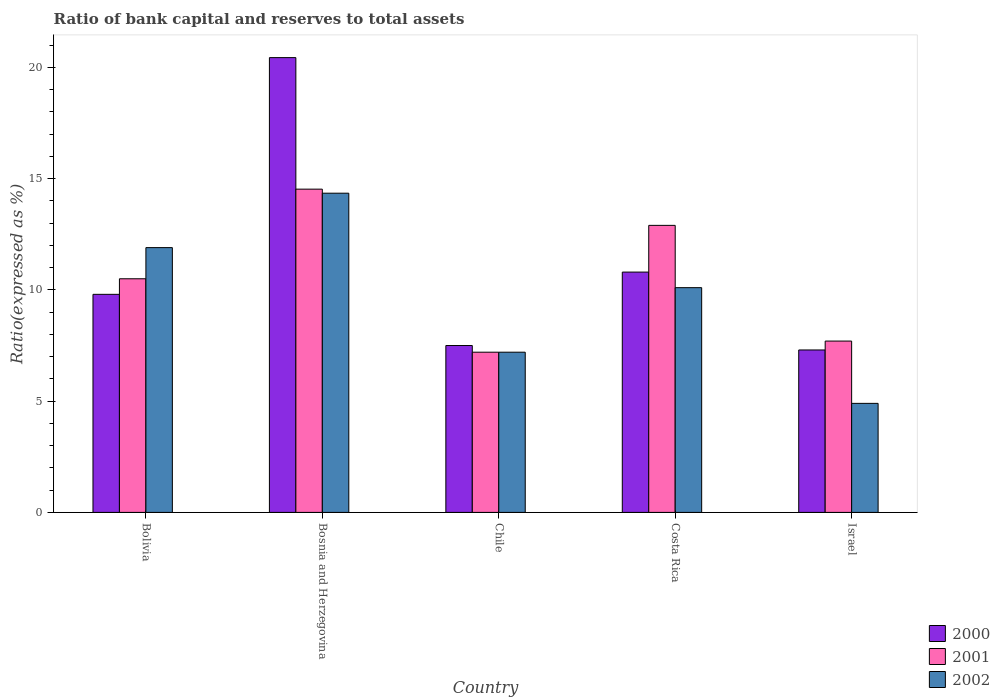Are the number of bars per tick equal to the number of legend labels?
Your response must be concise. Yes. In how many cases, is the number of bars for a given country not equal to the number of legend labels?
Provide a succinct answer. 0. Across all countries, what is the maximum ratio of bank capital and reserves to total assets in 2000?
Your answer should be very brief. 20.44. In which country was the ratio of bank capital and reserves to total assets in 2001 maximum?
Offer a terse response. Bosnia and Herzegovina. In which country was the ratio of bank capital and reserves to total assets in 2000 minimum?
Make the answer very short. Israel. What is the total ratio of bank capital and reserves to total assets in 2002 in the graph?
Your answer should be very brief. 48.45. What is the difference between the ratio of bank capital and reserves to total assets in 2001 in Chile and that in Costa Rica?
Your answer should be compact. -5.7. What is the difference between the ratio of bank capital and reserves to total assets in 2000 in Bosnia and Herzegovina and the ratio of bank capital and reserves to total assets in 2002 in Bolivia?
Your answer should be compact. 8.54. What is the average ratio of bank capital and reserves to total assets in 2002 per country?
Provide a short and direct response. 9.69. What is the difference between the ratio of bank capital and reserves to total assets of/in 2001 and ratio of bank capital and reserves to total assets of/in 2000 in Costa Rica?
Offer a terse response. 2.1. In how many countries, is the ratio of bank capital and reserves to total assets in 2002 greater than 4 %?
Provide a short and direct response. 5. What is the ratio of the ratio of bank capital and reserves to total assets in 2000 in Bosnia and Herzegovina to that in Costa Rica?
Offer a terse response. 1.89. What is the difference between the highest and the lowest ratio of bank capital and reserves to total assets in 2001?
Your answer should be compact. 7.33. How many countries are there in the graph?
Offer a terse response. 5. What is the difference between two consecutive major ticks on the Y-axis?
Provide a short and direct response. 5. Does the graph contain grids?
Ensure brevity in your answer.  No. Where does the legend appear in the graph?
Your answer should be compact. Bottom right. How many legend labels are there?
Ensure brevity in your answer.  3. How are the legend labels stacked?
Your answer should be compact. Vertical. What is the title of the graph?
Provide a succinct answer. Ratio of bank capital and reserves to total assets. Does "2012" appear as one of the legend labels in the graph?
Give a very brief answer. No. What is the label or title of the X-axis?
Keep it short and to the point. Country. What is the label or title of the Y-axis?
Ensure brevity in your answer.  Ratio(expressed as %). What is the Ratio(expressed as %) in 2000 in Bolivia?
Your response must be concise. 9.8. What is the Ratio(expressed as %) of 2000 in Bosnia and Herzegovina?
Your answer should be very brief. 20.44. What is the Ratio(expressed as %) of 2001 in Bosnia and Herzegovina?
Make the answer very short. 14.53. What is the Ratio(expressed as %) of 2002 in Bosnia and Herzegovina?
Provide a succinct answer. 14.35. What is the Ratio(expressed as %) in 2000 in Chile?
Your answer should be compact. 7.5. What is the Ratio(expressed as %) in 2002 in Costa Rica?
Make the answer very short. 10.1. What is the Ratio(expressed as %) of 2001 in Israel?
Your response must be concise. 7.7. Across all countries, what is the maximum Ratio(expressed as %) of 2000?
Keep it short and to the point. 20.44. Across all countries, what is the maximum Ratio(expressed as %) of 2001?
Your answer should be compact. 14.53. Across all countries, what is the maximum Ratio(expressed as %) of 2002?
Ensure brevity in your answer.  14.35. Across all countries, what is the minimum Ratio(expressed as %) in 2001?
Ensure brevity in your answer.  7.2. Across all countries, what is the minimum Ratio(expressed as %) of 2002?
Give a very brief answer. 4.9. What is the total Ratio(expressed as %) in 2000 in the graph?
Provide a short and direct response. 55.84. What is the total Ratio(expressed as %) of 2001 in the graph?
Your answer should be compact. 52.83. What is the total Ratio(expressed as %) of 2002 in the graph?
Ensure brevity in your answer.  48.45. What is the difference between the Ratio(expressed as %) in 2000 in Bolivia and that in Bosnia and Herzegovina?
Your answer should be very brief. -10.64. What is the difference between the Ratio(expressed as %) of 2001 in Bolivia and that in Bosnia and Herzegovina?
Your answer should be very brief. -4.03. What is the difference between the Ratio(expressed as %) of 2002 in Bolivia and that in Bosnia and Herzegovina?
Keep it short and to the point. -2.45. What is the difference between the Ratio(expressed as %) of 2001 in Bolivia and that in Chile?
Keep it short and to the point. 3.3. What is the difference between the Ratio(expressed as %) in 2002 in Bolivia and that in Chile?
Make the answer very short. 4.7. What is the difference between the Ratio(expressed as %) of 2000 in Bolivia and that in Costa Rica?
Offer a very short reply. -1. What is the difference between the Ratio(expressed as %) in 2001 in Bolivia and that in Costa Rica?
Offer a very short reply. -2.4. What is the difference between the Ratio(expressed as %) in 2002 in Bolivia and that in Costa Rica?
Provide a succinct answer. 1.8. What is the difference between the Ratio(expressed as %) in 2000 in Bosnia and Herzegovina and that in Chile?
Offer a very short reply. 12.94. What is the difference between the Ratio(expressed as %) of 2001 in Bosnia and Herzegovina and that in Chile?
Offer a terse response. 7.33. What is the difference between the Ratio(expressed as %) of 2002 in Bosnia and Herzegovina and that in Chile?
Give a very brief answer. 7.15. What is the difference between the Ratio(expressed as %) of 2000 in Bosnia and Herzegovina and that in Costa Rica?
Ensure brevity in your answer.  9.64. What is the difference between the Ratio(expressed as %) in 2001 in Bosnia and Herzegovina and that in Costa Rica?
Offer a very short reply. 1.63. What is the difference between the Ratio(expressed as %) of 2002 in Bosnia and Herzegovina and that in Costa Rica?
Offer a very short reply. 4.25. What is the difference between the Ratio(expressed as %) in 2000 in Bosnia and Herzegovina and that in Israel?
Provide a succinct answer. 13.14. What is the difference between the Ratio(expressed as %) of 2001 in Bosnia and Herzegovina and that in Israel?
Ensure brevity in your answer.  6.83. What is the difference between the Ratio(expressed as %) in 2002 in Bosnia and Herzegovina and that in Israel?
Make the answer very short. 9.45. What is the difference between the Ratio(expressed as %) in 2000 in Chile and that in Costa Rica?
Keep it short and to the point. -3.3. What is the difference between the Ratio(expressed as %) of 2002 in Chile and that in Costa Rica?
Offer a very short reply. -2.9. What is the difference between the Ratio(expressed as %) in 2000 in Chile and that in Israel?
Your answer should be compact. 0.2. What is the difference between the Ratio(expressed as %) in 2002 in Chile and that in Israel?
Keep it short and to the point. 2.3. What is the difference between the Ratio(expressed as %) in 2002 in Costa Rica and that in Israel?
Offer a terse response. 5.2. What is the difference between the Ratio(expressed as %) of 2000 in Bolivia and the Ratio(expressed as %) of 2001 in Bosnia and Herzegovina?
Ensure brevity in your answer.  -4.73. What is the difference between the Ratio(expressed as %) in 2000 in Bolivia and the Ratio(expressed as %) in 2002 in Bosnia and Herzegovina?
Ensure brevity in your answer.  -4.55. What is the difference between the Ratio(expressed as %) of 2001 in Bolivia and the Ratio(expressed as %) of 2002 in Bosnia and Herzegovina?
Your answer should be very brief. -3.85. What is the difference between the Ratio(expressed as %) in 2000 in Bolivia and the Ratio(expressed as %) in 2001 in Chile?
Your response must be concise. 2.6. What is the difference between the Ratio(expressed as %) of 2001 in Bolivia and the Ratio(expressed as %) of 2002 in Chile?
Give a very brief answer. 3.3. What is the difference between the Ratio(expressed as %) of 2000 in Bolivia and the Ratio(expressed as %) of 2001 in Costa Rica?
Provide a succinct answer. -3.1. What is the difference between the Ratio(expressed as %) in 2000 in Bolivia and the Ratio(expressed as %) in 2002 in Israel?
Offer a terse response. 4.9. What is the difference between the Ratio(expressed as %) of 2001 in Bolivia and the Ratio(expressed as %) of 2002 in Israel?
Provide a short and direct response. 5.6. What is the difference between the Ratio(expressed as %) of 2000 in Bosnia and Herzegovina and the Ratio(expressed as %) of 2001 in Chile?
Offer a very short reply. 13.24. What is the difference between the Ratio(expressed as %) in 2000 in Bosnia and Herzegovina and the Ratio(expressed as %) in 2002 in Chile?
Make the answer very short. 13.24. What is the difference between the Ratio(expressed as %) of 2001 in Bosnia and Herzegovina and the Ratio(expressed as %) of 2002 in Chile?
Ensure brevity in your answer.  7.33. What is the difference between the Ratio(expressed as %) of 2000 in Bosnia and Herzegovina and the Ratio(expressed as %) of 2001 in Costa Rica?
Make the answer very short. 7.54. What is the difference between the Ratio(expressed as %) in 2000 in Bosnia and Herzegovina and the Ratio(expressed as %) in 2002 in Costa Rica?
Your answer should be compact. 10.34. What is the difference between the Ratio(expressed as %) in 2001 in Bosnia and Herzegovina and the Ratio(expressed as %) in 2002 in Costa Rica?
Provide a short and direct response. 4.43. What is the difference between the Ratio(expressed as %) of 2000 in Bosnia and Herzegovina and the Ratio(expressed as %) of 2001 in Israel?
Provide a short and direct response. 12.74. What is the difference between the Ratio(expressed as %) of 2000 in Bosnia and Herzegovina and the Ratio(expressed as %) of 2002 in Israel?
Your answer should be very brief. 15.54. What is the difference between the Ratio(expressed as %) in 2001 in Bosnia and Herzegovina and the Ratio(expressed as %) in 2002 in Israel?
Your answer should be compact. 9.63. What is the difference between the Ratio(expressed as %) in 2000 in Chile and the Ratio(expressed as %) in 2001 in Costa Rica?
Your answer should be compact. -5.4. What is the difference between the Ratio(expressed as %) in 2001 in Chile and the Ratio(expressed as %) in 2002 in Costa Rica?
Provide a short and direct response. -2.9. What is the difference between the Ratio(expressed as %) of 2000 in Chile and the Ratio(expressed as %) of 2001 in Israel?
Make the answer very short. -0.2. What is the difference between the Ratio(expressed as %) in 2000 in Chile and the Ratio(expressed as %) in 2002 in Israel?
Make the answer very short. 2.6. What is the difference between the Ratio(expressed as %) of 2001 in Chile and the Ratio(expressed as %) of 2002 in Israel?
Give a very brief answer. 2.3. What is the difference between the Ratio(expressed as %) in 2000 in Costa Rica and the Ratio(expressed as %) in 2001 in Israel?
Your answer should be compact. 3.1. What is the average Ratio(expressed as %) in 2000 per country?
Your answer should be compact. 11.17. What is the average Ratio(expressed as %) in 2001 per country?
Your answer should be very brief. 10.57. What is the average Ratio(expressed as %) of 2002 per country?
Your answer should be very brief. 9.69. What is the difference between the Ratio(expressed as %) of 2000 and Ratio(expressed as %) of 2001 in Bosnia and Herzegovina?
Offer a terse response. 5.91. What is the difference between the Ratio(expressed as %) in 2000 and Ratio(expressed as %) in 2002 in Bosnia and Herzegovina?
Provide a succinct answer. 6.09. What is the difference between the Ratio(expressed as %) of 2001 and Ratio(expressed as %) of 2002 in Bosnia and Herzegovina?
Your response must be concise. 0.18. What is the difference between the Ratio(expressed as %) of 2000 and Ratio(expressed as %) of 2001 in Chile?
Offer a terse response. 0.3. What is the difference between the Ratio(expressed as %) of 2000 and Ratio(expressed as %) of 2002 in Chile?
Offer a very short reply. 0.3. What is the difference between the Ratio(expressed as %) of 2001 and Ratio(expressed as %) of 2002 in Chile?
Your response must be concise. 0. What is the difference between the Ratio(expressed as %) of 2000 and Ratio(expressed as %) of 2002 in Costa Rica?
Your answer should be compact. 0.7. What is the difference between the Ratio(expressed as %) in 2001 and Ratio(expressed as %) in 2002 in Costa Rica?
Make the answer very short. 2.8. What is the difference between the Ratio(expressed as %) in 2000 and Ratio(expressed as %) in 2002 in Israel?
Provide a succinct answer. 2.4. What is the difference between the Ratio(expressed as %) in 2001 and Ratio(expressed as %) in 2002 in Israel?
Offer a terse response. 2.8. What is the ratio of the Ratio(expressed as %) in 2000 in Bolivia to that in Bosnia and Herzegovina?
Offer a very short reply. 0.48. What is the ratio of the Ratio(expressed as %) in 2001 in Bolivia to that in Bosnia and Herzegovina?
Offer a very short reply. 0.72. What is the ratio of the Ratio(expressed as %) of 2002 in Bolivia to that in Bosnia and Herzegovina?
Provide a succinct answer. 0.83. What is the ratio of the Ratio(expressed as %) of 2000 in Bolivia to that in Chile?
Give a very brief answer. 1.31. What is the ratio of the Ratio(expressed as %) in 2001 in Bolivia to that in Chile?
Your answer should be compact. 1.46. What is the ratio of the Ratio(expressed as %) in 2002 in Bolivia to that in Chile?
Provide a short and direct response. 1.65. What is the ratio of the Ratio(expressed as %) of 2000 in Bolivia to that in Costa Rica?
Your answer should be very brief. 0.91. What is the ratio of the Ratio(expressed as %) of 2001 in Bolivia to that in Costa Rica?
Give a very brief answer. 0.81. What is the ratio of the Ratio(expressed as %) in 2002 in Bolivia to that in Costa Rica?
Give a very brief answer. 1.18. What is the ratio of the Ratio(expressed as %) in 2000 in Bolivia to that in Israel?
Make the answer very short. 1.34. What is the ratio of the Ratio(expressed as %) of 2001 in Bolivia to that in Israel?
Keep it short and to the point. 1.36. What is the ratio of the Ratio(expressed as %) in 2002 in Bolivia to that in Israel?
Keep it short and to the point. 2.43. What is the ratio of the Ratio(expressed as %) of 2000 in Bosnia and Herzegovina to that in Chile?
Offer a very short reply. 2.73. What is the ratio of the Ratio(expressed as %) in 2001 in Bosnia and Herzegovina to that in Chile?
Your response must be concise. 2.02. What is the ratio of the Ratio(expressed as %) of 2002 in Bosnia and Herzegovina to that in Chile?
Keep it short and to the point. 1.99. What is the ratio of the Ratio(expressed as %) in 2000 in Bosnia and Herzegovina to that in Costa Rica?
Your answer should be compact. 1.89. What is the ratio of the Ratio(expressed as %) of 2001 in Bosnia and Herzegovina to that in Costa Rica?
Keep it short and to the point. 1.13. What is the ratio of the Ratio(expressed as %) in 2002 in Bosnia and Herzegovina to that in Costa Rica?
Your answer should be compact. 1.42. What is the ratio of the Ratio(expressed as %) in 2000 in Bosnia and Herzegovina to that in Israel?
Your answer should be compact. 2.8. What is the ratio of the Ratio(expressed as %) of 2001 in Bosnia and Herzegovina to that in Israel?
Your response must be concise. 1.89. What is the ratio of the Ratio(expressed as %) in 2002 in Bosnia and Herzegovina to that in Israel?
Offer a terse response. 2.93. What is the ratio of the Ratio(expressed as %) in 2000 in Chile to that in Costa Rica?
Provide a succinct answer. 0.69. What is the ratio of the Ratio(expressed as %) of 2001 in Chile to that in Costa Rica?
Give a very brief answer. 0.56. What is the ratio of the Ratio(expressed as %) in 2002 in Chile to that in Costa Rica?
Your response must be concise. 0.71. What is the ratio of the Ratio(expressed as %) in 2000 in Chile to that in Israel?
Make the answer very short. 1.03. What is the ratio of the Ratio(expressed as %) of 2001 in Chile to that in Israel?
Give a very brief answer. 0.94. What is the ratio of the Ratio(expressed as %) in 2002 in Chile to that in Israel?
Your answer should be very brief. 1.47. What is the ratio of the Ratio(expressed as %) of 2000 in Costa Rica to that in Israel?
Provide a short and direct response. 1.48. What is the ratio of the Ratio(expressed as %) in 2001 in Costa Rica to that in Israel?
Keep it short and to the point. 1.68. What is the ratio of the Ratio(expressed as %) of 2002 in Costa Rica to that in Israel?
Ensure brevity in your answer.  2.06. What is the difference between the highest and the second highest Ratio(expressed as %) of 2000?
Give a very brief answer. 9.64. What is the difference between the highest and the second highest Ratio(expressed as %) of 2001?
Provide a short and direct response. 1.63. What is the difference between the highest and the second highest Ratio(expressed as %) of 2002?
Provide a short and direct response. 2.45. What is the difference between the highest and the lowest Ratio(expressed as %) of 2000?
Ensure brevity in your answer.  13.14. What is the difference between the highest and the lowest Ratio(expressed as %) in 2001?
Provide a succinct answer. 7.33. What is the difference between the highest and the lowest Ratio(expressed as %) in 2002?
Keep it short and to the point. 9.45. 